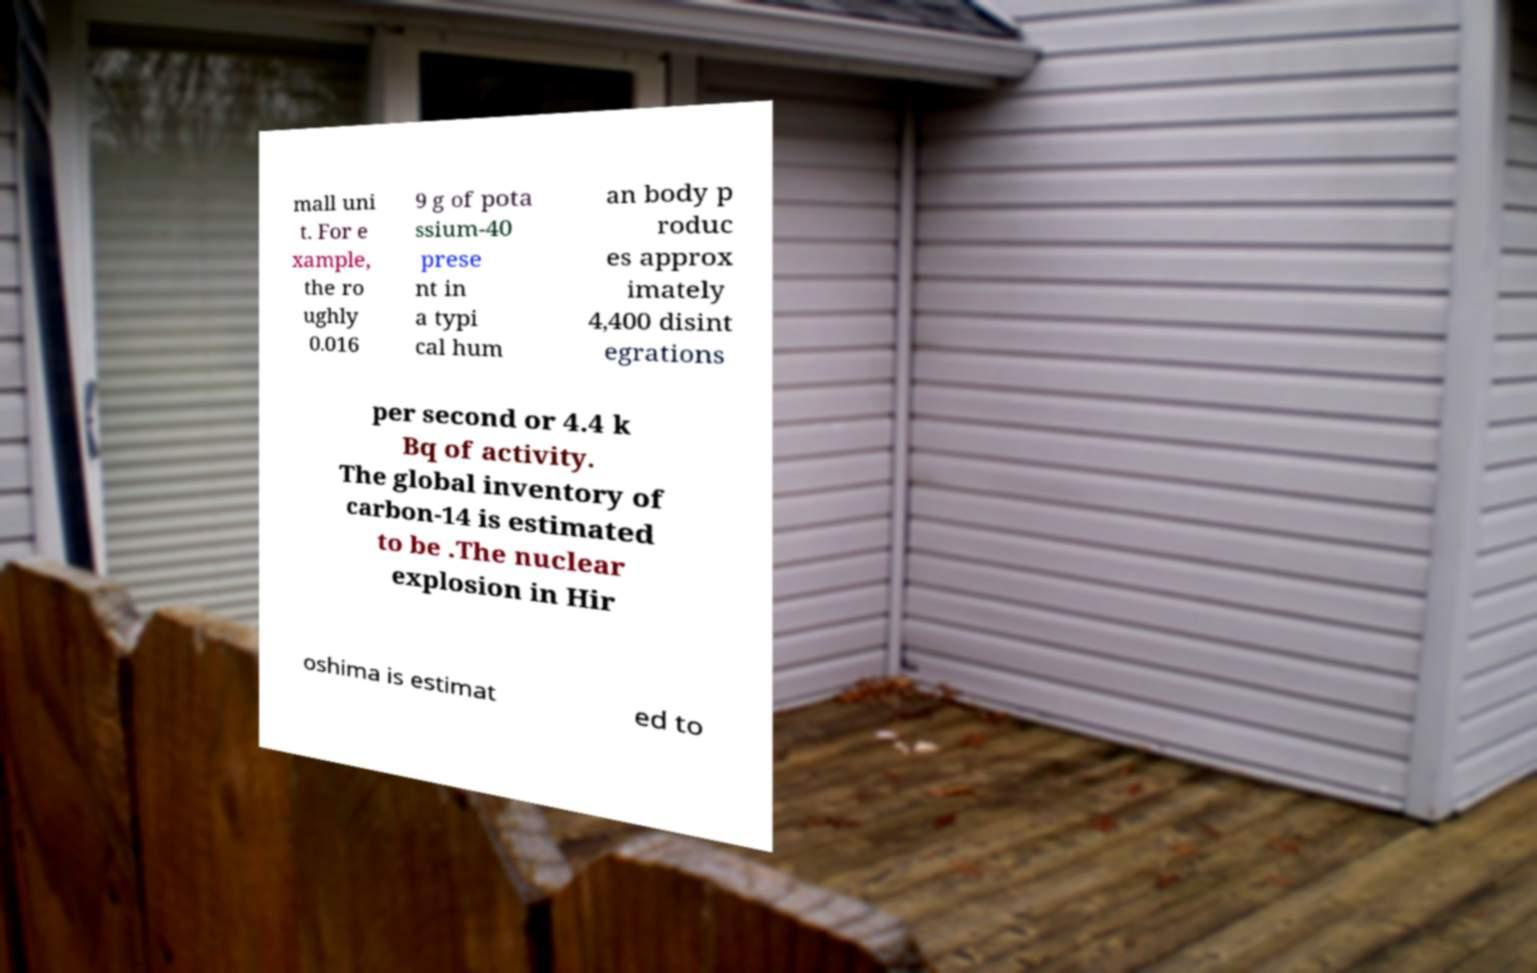There's text embedded in this image that I need extracted. Can you transcribe it verbatim? mall uni t. For e xample, the ro ughly 0.016 9 g of pota ssium-40 prese nt in a typi cal hum an body p roduc es approx imately 4,400 disint egrations per second or 4.4 k Bq of activity. The global inventory of carbon-14 is estimated to be .The nuclear explosion in Hir oshima is estimat ed to 